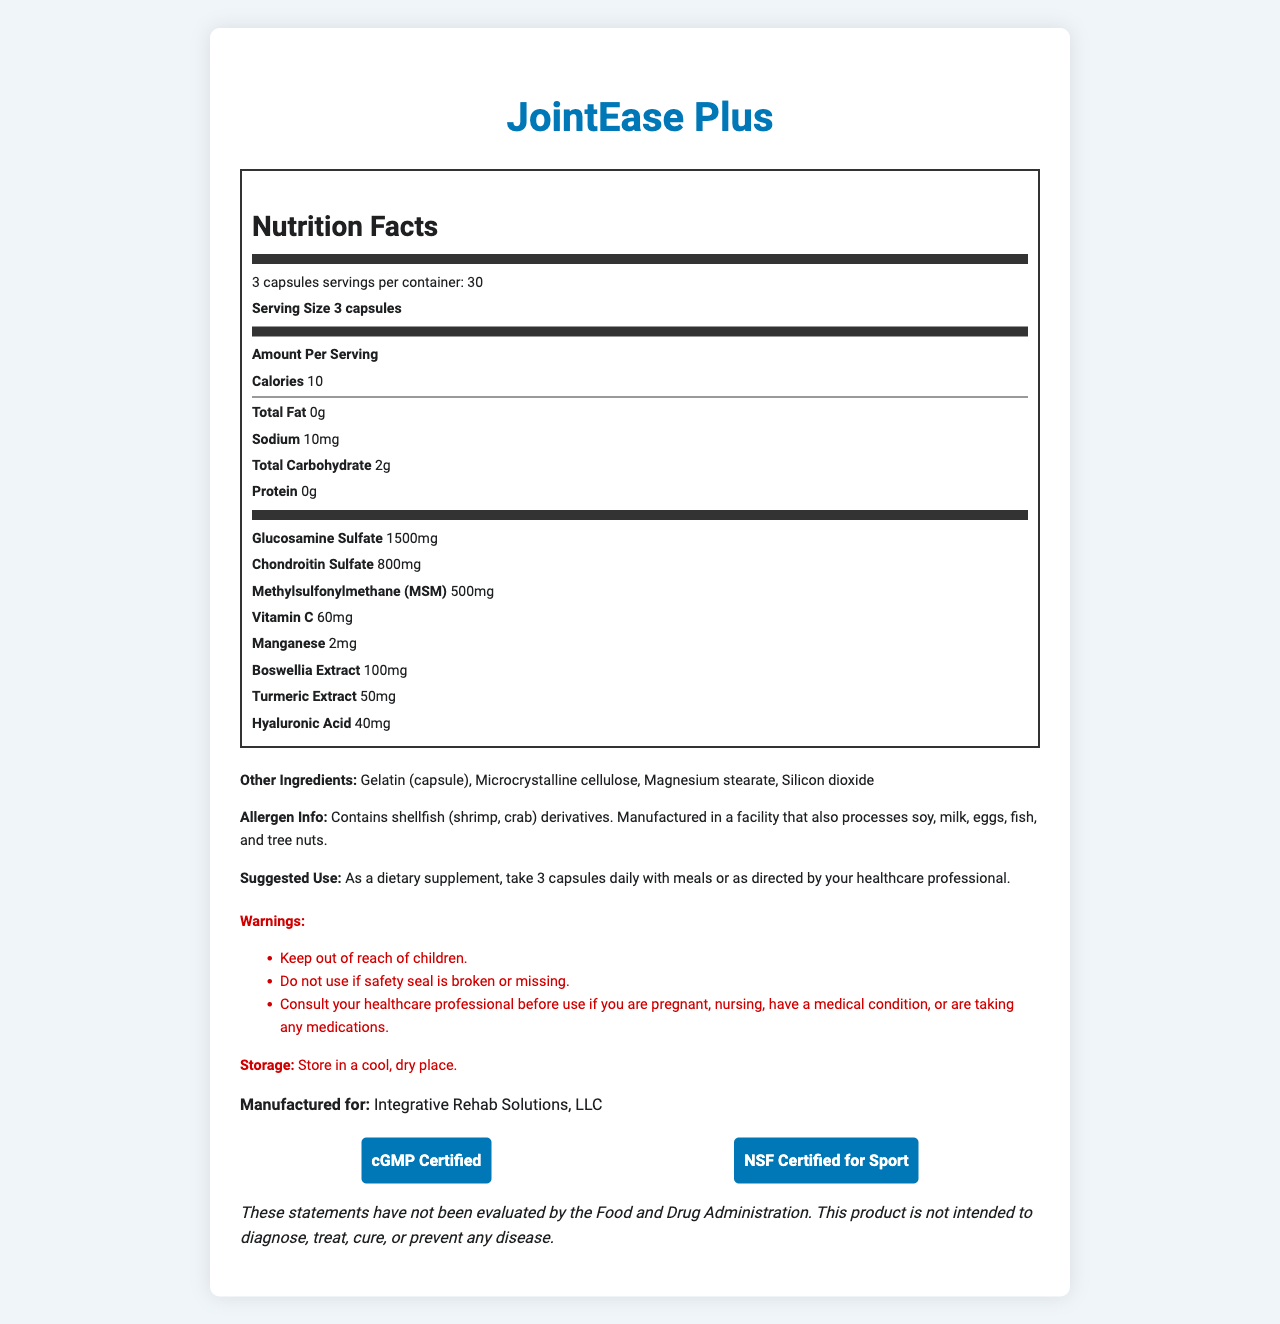what is the serving size for JointEase Plus? The serving size is clearly stated in the document as "3 capsules."
Answer: 3 capsules how many servings are there per container of JointEase Plus? The document specifies that there are 30 servings per container.
Answer: 30 servings how many calories are in each serving of JointEase Plus? The document lists the calorie content per serving as 10 calories.
Answer: 10 calories what is the amount of glucosamine sulfate per serving? The amount of glucosamine sulfate per serving is specified as 1500mg.
Answer: 1500mg what are the main active ingredients in JointEase Plus? These active ingredients are listed under the "Amount Per Serving" section of the nutrition label.
Answer: Glucosamine sulfate, chondroitin sulfate, methylsulfonylmethane (MSM), vitamin C, manganese, boswellia extract, turmeric extract, hyaluronic acid what allergens are present in JointEase Plus? The document mentions that the supplement contains shellfish derivatives (shrimp, crab).
Answer: Contains shellfish (shrimp, crab) derivatives What are the suggested use instructions for JointEase Plus? A. Take 1 capsule daily B. Take 2 capsules daily C. Take 3 capsules daily with meals D. Take 4 capsules daily The document suggests taking 3 capsules daily with meals or as directed by a healthcare professional.
Answer: C What is the total carbohydrate content per serving of JointEase Plus? A. 0g B. 1g C. 2g D. 3g The document specifies that the total carbohydrate content per serving is 2g.
Answer: C Is JointEase Plus manufactured in a facility that processes tree nuts? The allergen information specifies that the product is manufactured in a facility that also processes tree nuts.
Answer: Yes Is JointEase Plus cGMP Certified? The document states that JointEase Plus is cGMP Certified under the certifications section.
Answer: Yes Summarize the main idea of the JointEase Plus document. This summary captures the essential details about the product's composition, nutritional information, usage instructions, and certifications.
Answer: JointEase Plus is a joint support supplement containing glucosamine sulfate, chondroitin sulfate, and MSM, along with other ingredients like vitamin C, manganese, boswellia extract, turmeric extract, and hyaluronic acid. It comes in a container with 30 servings, with a serving size of 3 capsules providing 10 calories. The document provides nutritional information, allergen warnings, suggested use instructions, and certifications like cGMP and NSF for Sport. Who manufactures JointEase Plus? The document indicates that the product is manufactured for Integrative Rehab Solutions, LLC.
Answer: Integrative Rehab Solutions, LLC Does JointEase Plus contain magnesium stearate as an ingredient? Magnesium stearate is listed under the "Other Ingredients" section.
Answer: Yes What is the purpose of the disclaimer at the end of the document? The disclaimer clarifies the regulatory status and intended use of the product.
Answer: To state that the product's statements have not been evaluated by the FDA and that it is not intended to diagnose, treat, cure, or prevent any disease. What is the exact amount of sodium in each serving of JointEase Plus? The document lists the sodium content per serving as 10mg.
Answer: 10mg What is the warning related to the safety seal of JointEase Plus? The document advises not to use the product if the safety seal is broken or missing.
Answer: Do not use if safety seal is broken or missing. How many mg of Boswellia Extract are in each serving? The document specifies that there are 100mg of Boswellia Extract per serving.
Answer: 100mg What is the daily value percentage for vitamin C in JointEase Plus? The document does not provide the percentage of daily value for vitamin C.
Answer: Cannot be determined How should JointEase Plus be stored? The document advises storing the product in a cool, dry place.
Answer: Store in a cool, dry place. 